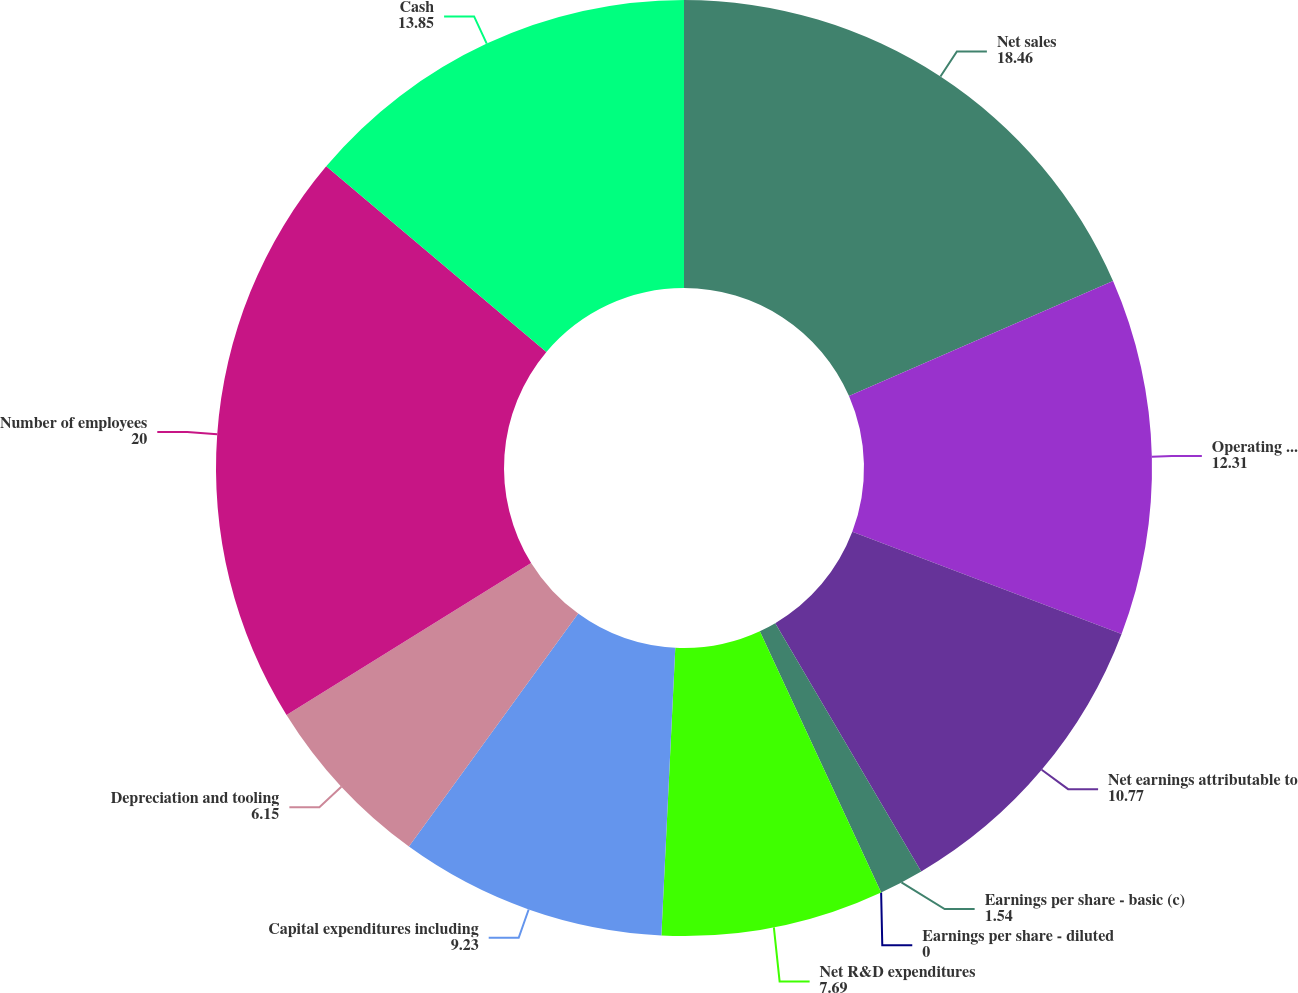<chart> <loc_0><loc_0><loc_500><loc_500><pie_chart><fcel>Net sales<fcel>Operating income (b)<fcel>Net earnings attributable to<fcel>Earnings per share - basic (c)<fcel>Earnings per share - diluted<fcel>Net R&D expenditures<fcel>Capital expenditures including<fcel>Depreciation and tooling<fcel>Number of employees<fcel>Cash<nl><fcel>18.46%<fcel>12.31%<fcel>10.77%<fcel>1.54%<fcel>0.0%<fcel>7.69%<fcel>9.23%<fcel>6.15%<fcel>20.0%<fcel>13.85%<nl></chart> 